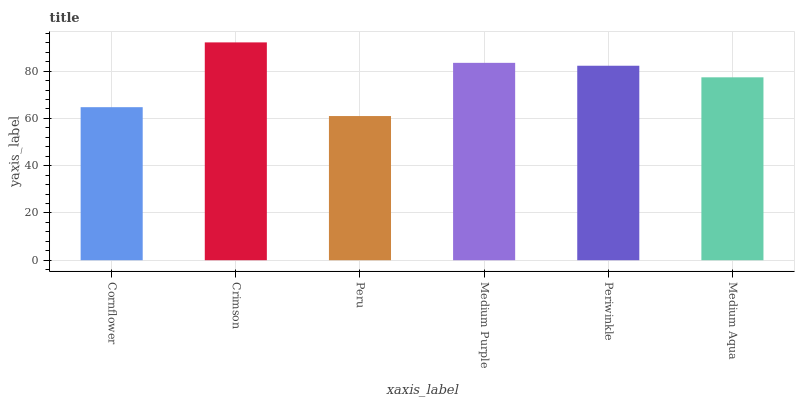Is Peru the minimum?
Answer yes or no. Yes. Is Crimson the maximum?
Answer yes or no. Yes. Is Crimson the minimum?
Answer yes or no. No. Is Peru the maximum?
Answer yes or no. No. Is Crimson greater than Peru?
Answer yes or no. Yes. Is Peru less than Crimson?
Answer yes or no. Yes. Is Peru greater than Crimson?
Answer yes or no. No. Is Crimson less than Peru?
Answer yes or no. No. Is Periwinkle the high median?
Answer yes or no. Yes. Is Medium Aqua the low median?
Answer yes or no. Yes. Is Cornflower the high median?
Answer yes or no. No. Is Periwinkle the low median?
Answer yes or no. No. 